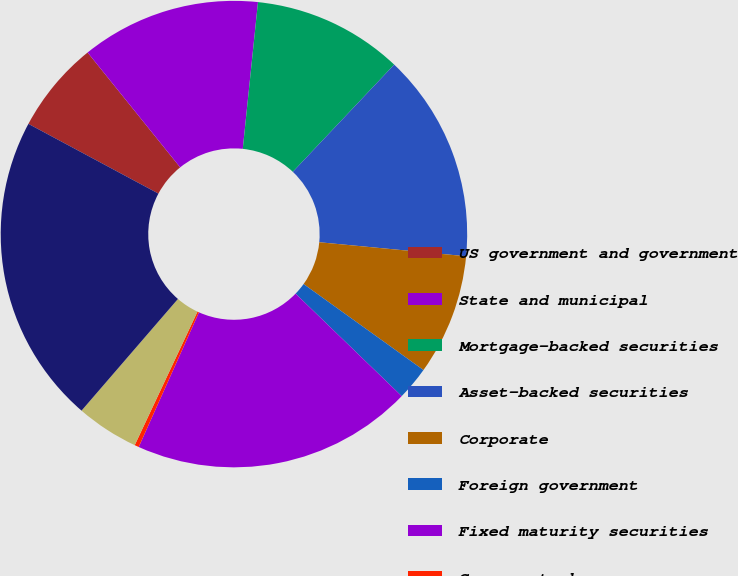Convert chart. <chart><loc_0><loc_0><loc_500><loc_500><pie_chart><fcel>US government and government<fcel>State and municipal<fcel>Mortgage-backed securities<fcel>Asset-backed securities<fcel>Corporate<fcel>Foreign government<fcel>Fixed maturity securities<fcel>Common stocks<fcel>Equity securities available<fcel>Total<nl><fcel>6.37%<fcel>12.44%<fcel>10.41%<fcel>14.46%<fcel>8.39%<fcel>2.32%<fcel>19.47%<fcel>0.3%<fcel>4.34%<fcel>21.5%<nl></chart> 